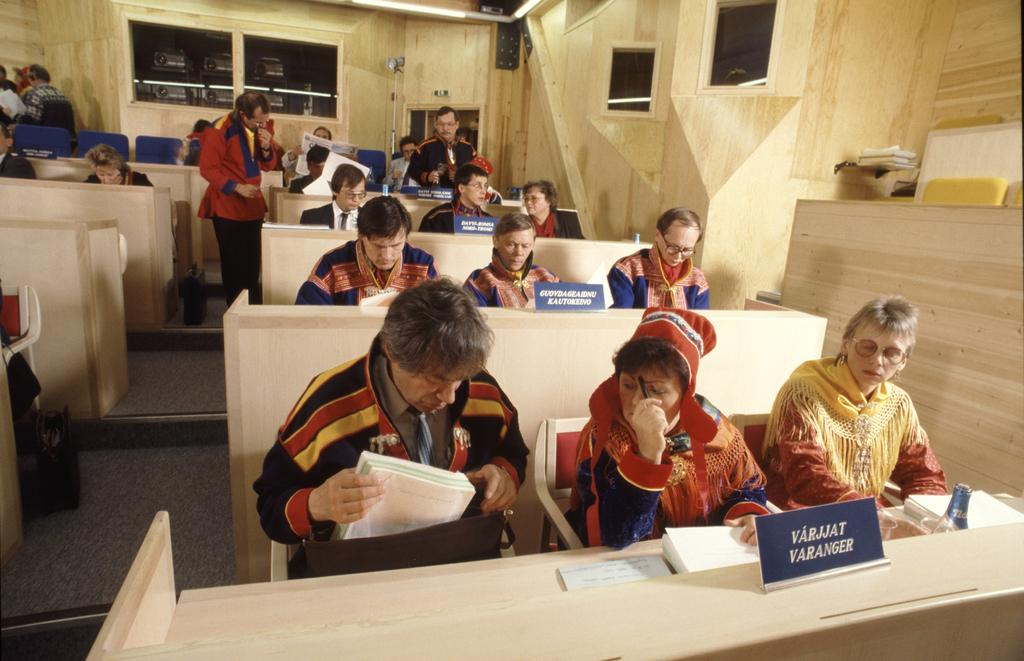What is the main activity of the people in the image? The group of people is sitting on chairs in the image. Where are the chairs located in relation to the desk? The chairs are in front of a desk in the image. What is the position of the man in the image? The man is standing on the floor in the image. What song is being sung by the people sitting on chairs in the image? There is no indication in the image that the people are singing a song. 